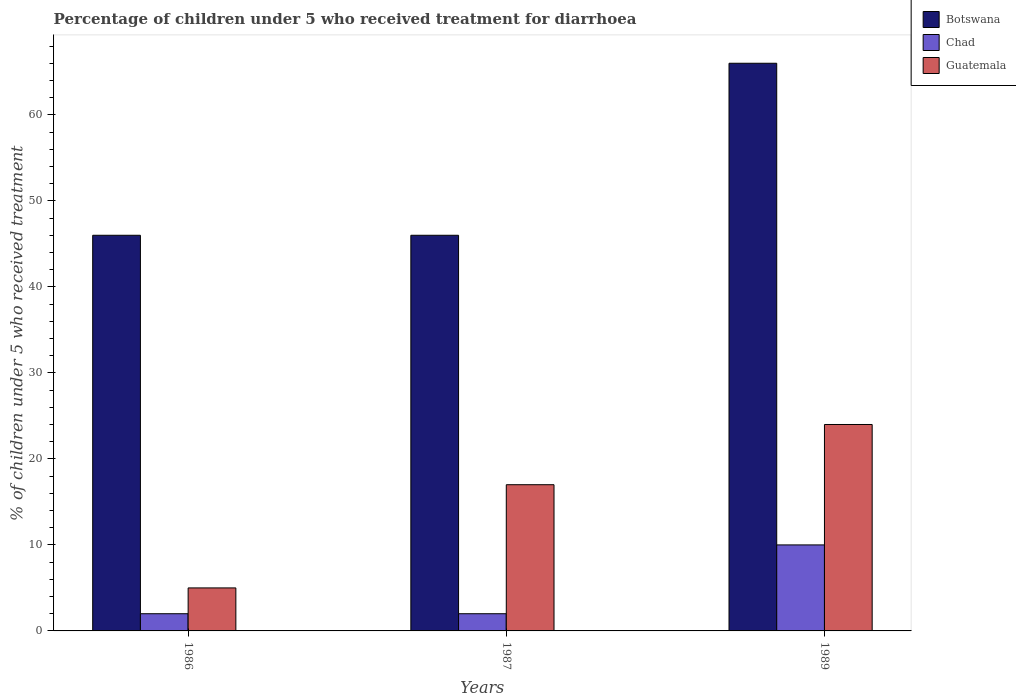How many groups of bars are there?
Provide a short and direct response. 3. Are the number of bars per tick equal to the number of legend labels?
Make the answer very short. Yes. Are the number of bars on each tick of the X-axis equal?
Offer a terse response. Yes. How many bars are there on the 1st tick from the left?
Provide a succinct answer. 3. How many bars are there on the 3rd tick from the right?
Offer a very short reply. 3. In which year was the percentage of children who received treatment for diarrhoea  in Guatemala maximum?
Provide a succinct answer. 1989. What is the total percentage of children who received treatment for diarrhoea  in Botswana in the graph?
Provide a short and direct response. 158. What is the difference between the percentage of children who received treatment for diarrhoea  in Chad in 1986 and that in 1989?
Offer a terse response. -8. What is the difference between the percentage of children who received treatment for diarrhoea  in Chad in 1987 and the percentage of children who received treatment for diarrhoea  in Guatemala in 1989?
Make the answer very short. -22. What is the average percentage of children who received treatment for diarrhoea  in Botswana per year?
Provide a succinct answer. 52.67. In how many years, is the percentage of children who received treatment for diarrhoea  in Botswana greater than 62 %?
Offer a very short reply. 1. Is the percentage of children who received treatment for diarrhoea  in Botswana in 1986 less than that in 1987?
Provide a short and direct response. No. What is the difference between the highest and the second highest percentage of children who received treatment for diarrhoea  in Botswana?
Ensure brevity in your answer.  20. In how many years, is the percentage of children who received treatment for diarrhoea  in Chad greater than the average percentage of children who received treatment for diarrhoea  in Chad taken over all years?
Make the answer very short. 1. What does the 3rd bar from the left in 1989 represents?
Provide a short and direct response. Guatemala. What does the 3rd bar from the right in 1986 represents?
Ensure brevity in your answer.  Botswana. Is it the case that in every year, the sum of the percentage of children who received treatment for diarrhoea  in Botswana and percentage of children who received treatment for diarrhoea  in Guatemala is greater than the percentage of children who received treatment for diarrhoea  in Chad?
Your response must be concise. Yes. How many bars are there?
Keep it short and to the point. 9. Are the values on the major ticks of Y-axis written in scientific E-notation?
Ensure brevity in your answer.  No. Does the graph contain any zero values?
Make the answer very short. No. Where does the legend appear in the graph?
Your response must be concise. Top right. What is the title of the graph?
Your response must be concise. Percentage of children under 5 who received treatment for diarrhoea. Does "Middle income" appear as one of the legend labels in the graph?
Your answer should be very brief. No. What is the label or title of the Y-axis?
Ensure brevity in your answer.  % of children under 5 who received treatment. What is the % of children under 5 who received treatment of Chad in 1986?
Provide a short and direct response. 2. What is the % of children under 5 who received treatment of Guatemala in 1987?
Your answer should be compact. 17. What is the % of children under 5 who received treatment of Chad in 1989?
Your response must be concise. 10. What is the % of children under 5 who received treatment of Guatemala in 1989?
Provide a succinct answer. 24. Across all years, what is the maximum % of children under 5 who received treatment in Chad?
Keep it short and to the point. 10. Across all years, what is the minimum % of children under 5 who received treatment of Chad?
Ensure brevity in your answer.  2. What is the total % of children under 5 who received treatment of Botswana in the graph?
Your response must be concise. 158. What is the difference between the % of children under 5 who received treatment in Guatemala in 1986 and that in 1989?
Offer a terse response. -19. What is the difference between the % of children under 5 who received treatment of Chad in 1987 and that in 1989?
Your answer should be compact. -8. What is the difference between the % of children under 5 who received treatment of Guatemala in 1987 and that in 1989?
Provide a succinct answer. -7. What is the difference between the % of children under 5 who received treatment in Botswana in 1986 and the % of children under 5 who received treatment in Chad in 1987?
Your answer should be very brief. 44. What is the difference between the % of children under 5 who received treatment in Botswana in 1986 and the % of children under 5 who received treatment in Guatemala in 1987?
Ensure brevity in your answer.  29. What is the difference between the % of children under 5 who received treatment in Botswana in 1986 and the % of children under 5 who received treatment in Guatemala in 1989?
Provide a succinct answer. 22. What is the average % of children under 5 who received treatment of Botswana per year?
Offer a very short reply. 52.67. What is the average % of children under 5 who received treatment in Chad per year?
Ensure brevity in your answer.  4.67. What is the average % of children under 5 who received treatment in Guatemala per year?
Offer a very short reply. 15.33. In the year 1986, what is the difference between the % of children under 5 who received treatment in Botswana and % of children under 5 who received treatment in Guatemala?
Keep it short and to the point. 41. In the year 1987, what is the difference between the % of children under 5 who received treatment in Chad and % of children under 5 who received treatment in Guatemala?
Provide a short and direct response. -15. In the year 1989, what is the difference between the % of children under 5 who received treatment in Botswana and % of children under 5 who received treatment in Chad?
Make the answer very short. 56. What is the ratio of the % of children under 5 who received treatment of Botswana in 1986 to that in 1987?
Keep it short and to the point. 1. What is the ratio of the % of children under 5 who received treatment of Chad in 1986 to that in 1987?
Your answer should be compact. 1. What is the ratio of the % of children under 5 who received treatment in Guatemala in 1986 to that in 1987?
Your response must be concise. 0.29. What is the ratio of the % of children under 5 who received treatment in Botswana in 1986 to that in 1989?
Provide a short and direct response. 0.7. What is the ratio of the % of children under 5 who received treatment in Chad in 1986 to that in 1989?
Provide a succinct answer. 0.2. What is the ratio of the % of children under 5 who received treatment in Guatemala in 1986 to that in 1989?
Provide a short and direct response. 0.21. What is the ratio of the % of children under 5 who received treatment of Botswana in 1987 to that in 1989?
Provide a short and direct response. 0.7. What is the ratio of the % of children under 5 who received treatment in Guatemala in 1987 to that in 1989?
Keep it short and to the point. 0.71. What is the difference between the highest and the second highest % of children under 5 who received treatment of Botswana?
Offer a terse response. 20. What is the difference between the highest and the second highest % of children under 5 who received treatment of Chad?
Offer a very short reply. 8. What is the difference between the highest and the second highest % of children under 5 who received treatment of Guatemala?
Give a very brief answer. 7. What is the difference between the highest and the lowest % of children under 5 who received treatment in Chad?
Ensure brevity in your answer.  8. What is the difference between the highest and the lowest % of children under 5 who received treatment in Guatemala?
Your answer should be very brief. 19. 